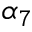Convert formula to latex. <formula><loc_0><loc_0><loc_500><loc_500>\alpha _ { 7 }</formula> 